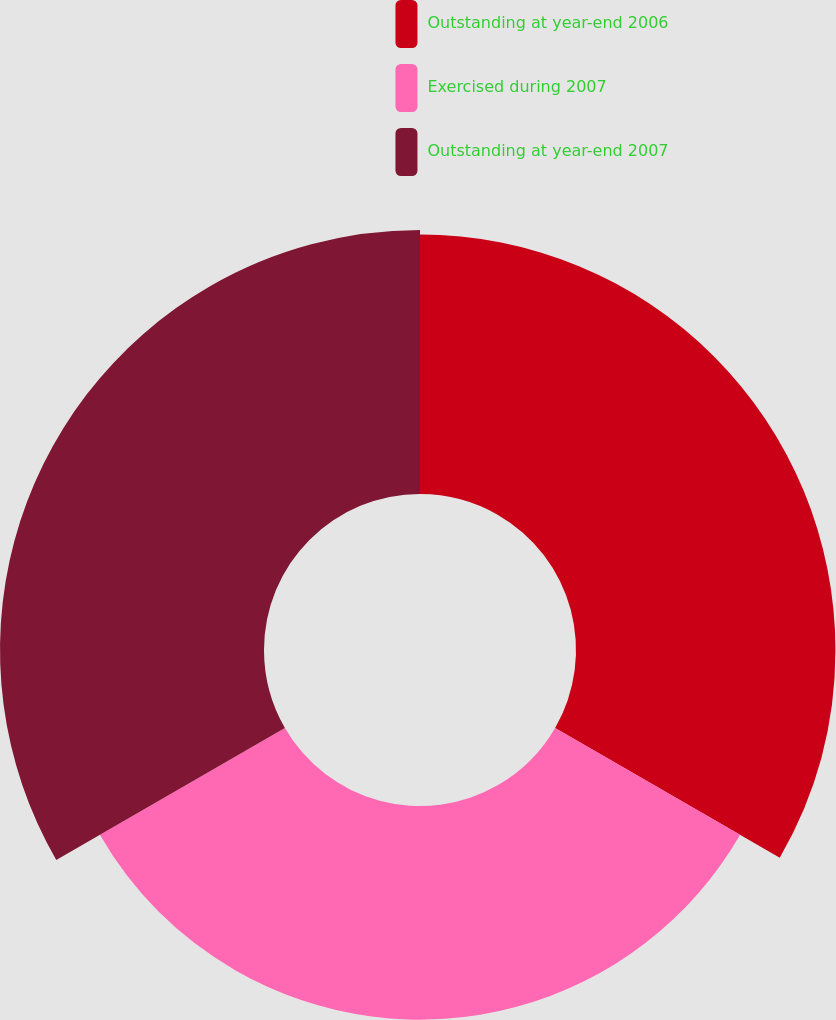Convert chart. <chart><loc_0><loc_0><loc_500><loc_500><pie_chart><fcel>Outstanding at year-end 2006<fcel>Exercised during 2007<fcel>Outstanding at year-end 2007<nl><fcel>35.2%<fcel>28.99%<fcel>35.82%<nl></chart> 